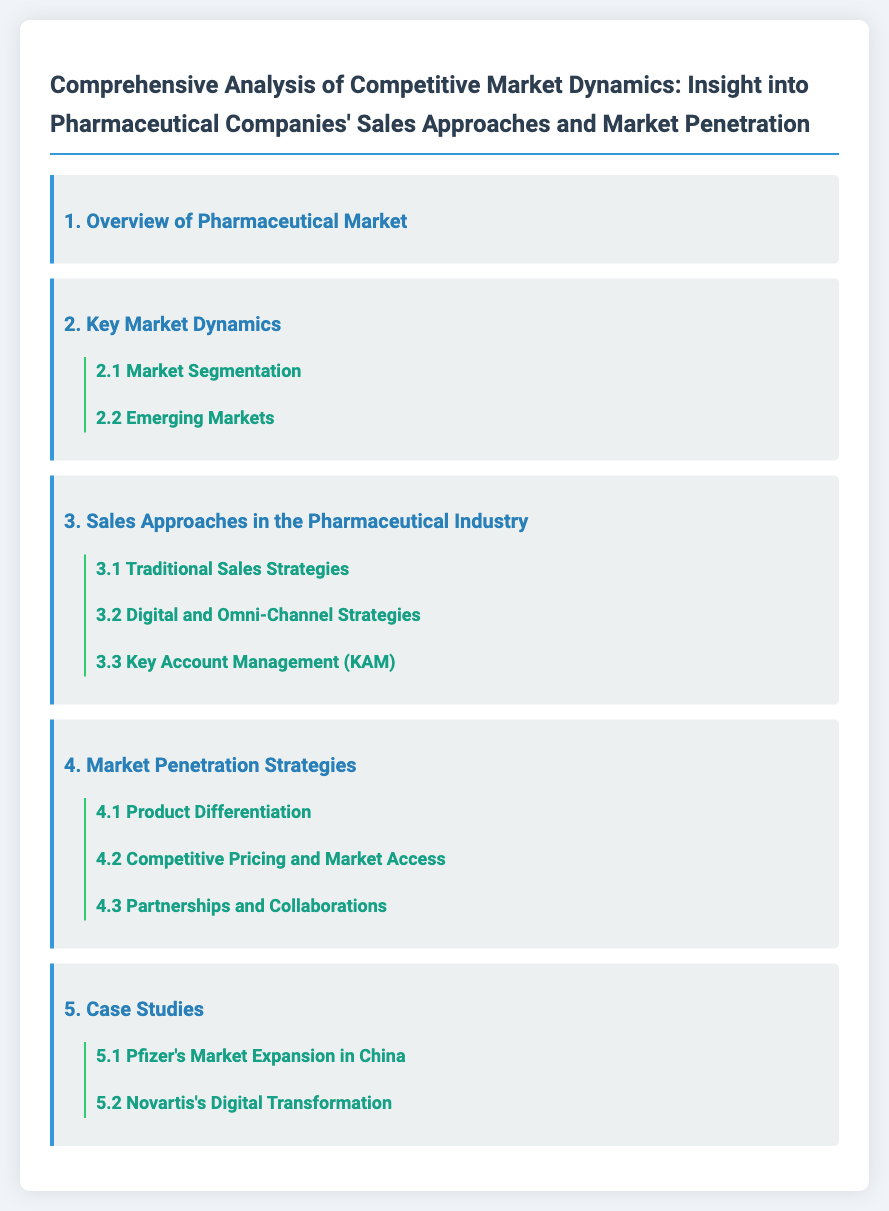What is the title of the document? The title of the document provides an overview of the content and purpose, which is "Comprehensive Analysis of Competitive Market Dynamics: Insight into Pharmaceutical Companies' Sales Approaches and Market Penetration."
Answer: Comprehensive Analysis of Competitive Market Dynamics: Insight into Pharmaceutical Companies' Sales Approaches and Market Penetration How many key market dynamics are listed? The document outlines a total of two key market dynamics in section 2.
Answer: 2 What is one of the sales approaches mentioned in the document? The document lists multiple sales approaches under section 3, one of which is "Digital and Omni-Channel Strategies."
Answer: Digital and Omni-Channel Strategies Which company is highlighted for its market expansion in China? Section 5 provides case studies and mentions "Pfizer's Market Expansion in China" as a focus.
Answer: Pfizer What strategy focuses on differentiating products in the market? The document refers to "Product Differentiation" as a market penetration strategy.
Answer: Product Differentiation What is emphasized under emerging markets? "Emerging Markets" is a subsection in key market dynamics, indicating its importance but not providing specific details in this question.
Answer: Emerging Markets How many case studies are included in this document? The document presents a total of two case studies in section 5.
Answer: 2 